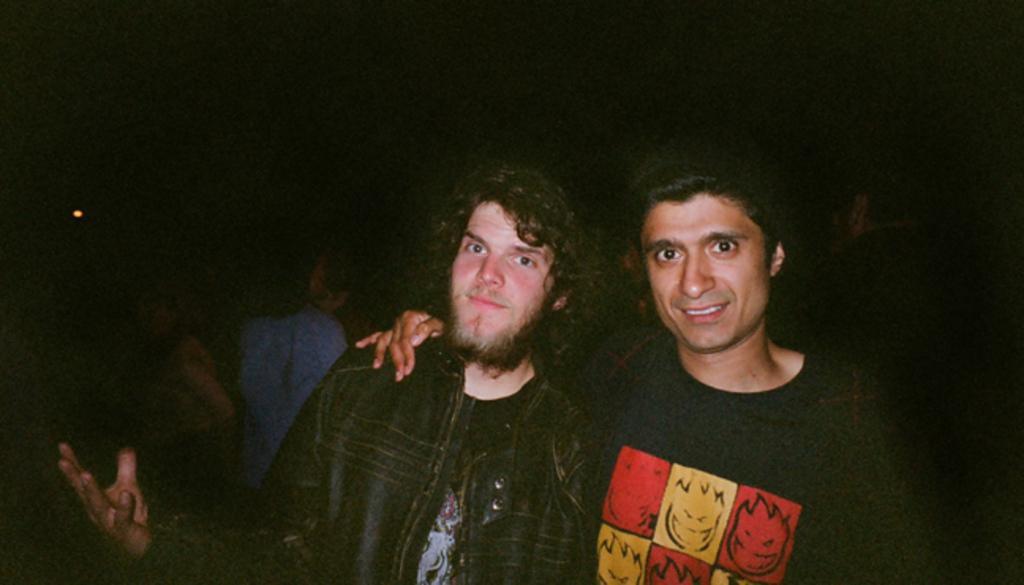Please provide a concise description of this image. In this picture there are two people in the center of the image and there are other people in the background area of the image. 